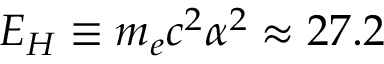<formula> <loc_0><loc_0><loc_500><loc_500>E _ { H } \equiv m _ { e } c ^ { 2 } \alpha ^ { 2 } \approx 2 7 . 2</formula> 